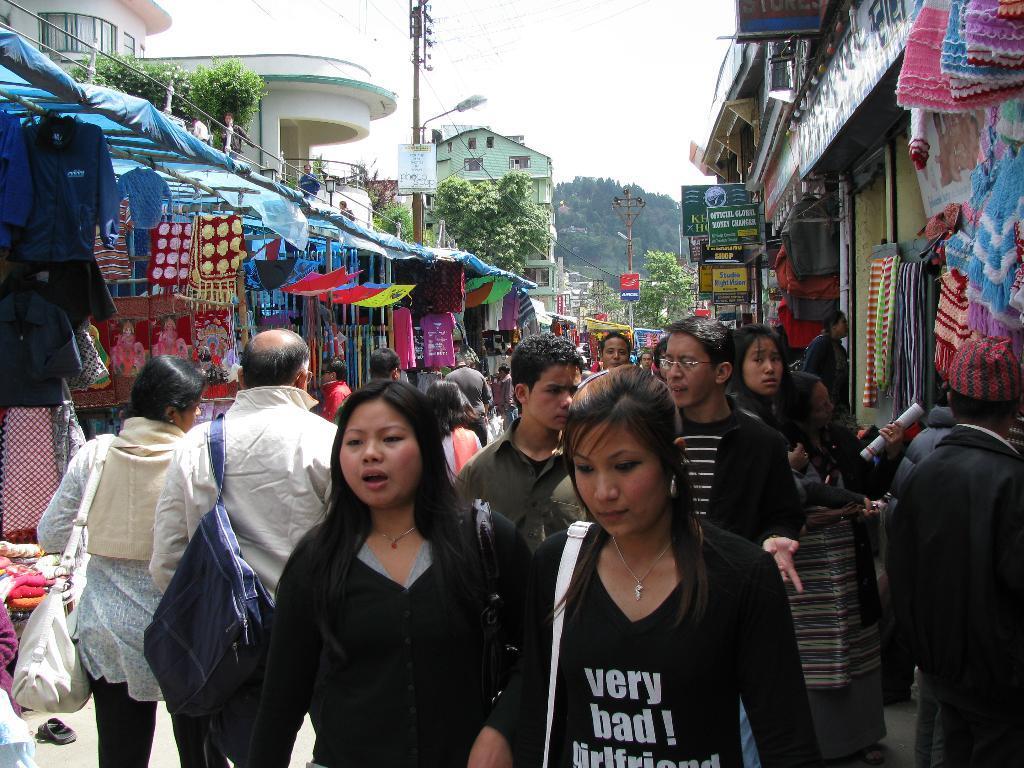How would you summarize this image in a sentence or two? In this image there are group of people who are walking and some of them are talking, and some of them are wearing bags and some of them are holding something. On the right side and left side there are some stores, and in the stores we could see some clothes, dresses and some other objects. In the background there are some buildings, poles, street lights, wires. At the bottom there is a walkway. 